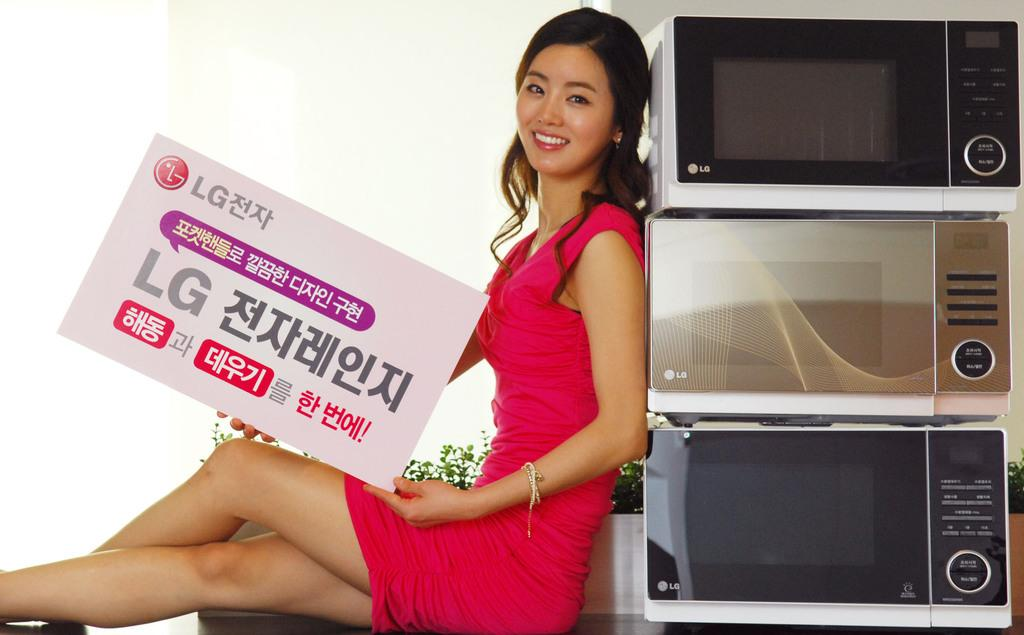Provide a one-sentence caption for the provided image. A model leans next to microwaves while holding a sign advertising for LG. 